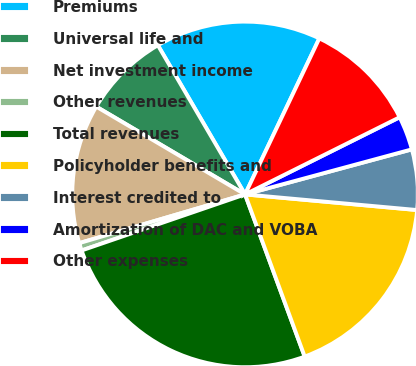<chart> <loc_0><loc_0><loc_500><loc_500><pie_chart><fcel>Premiums<fcel>Universal life and<fcel>Net investment income<fcel>Other revenues<fcel>Total revenues<fcel>Policyholder benefits and<fcel>Interest credited to<fcel>Amortization of DAC and VOBA<fcel>Other expenses<nl><fcel>15.49%<fcel>8.1%<fcel>13.03%<fcel>0.71%<fcel>25.35%<fcel>17.95%<fcel>5.64%<fcel>3.17%<fcel>10.56%<nl></chart> 